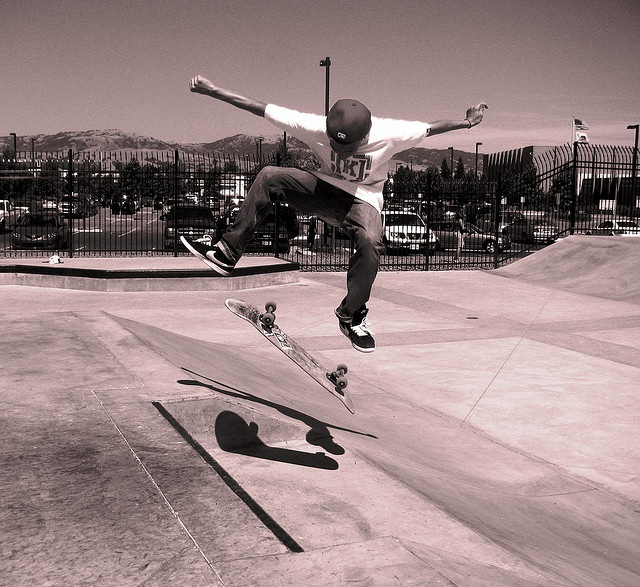Describe the objects in this image and their specific colors. I can see people in gray, black, darkgray, and white tones, skateboard in gray, darkgray, pink, and black tones, car in gray, black, white, and darkgray tones, car in gray, black, white, and darkgray tones, and car in gray, black, and darkgray tones in this image. 